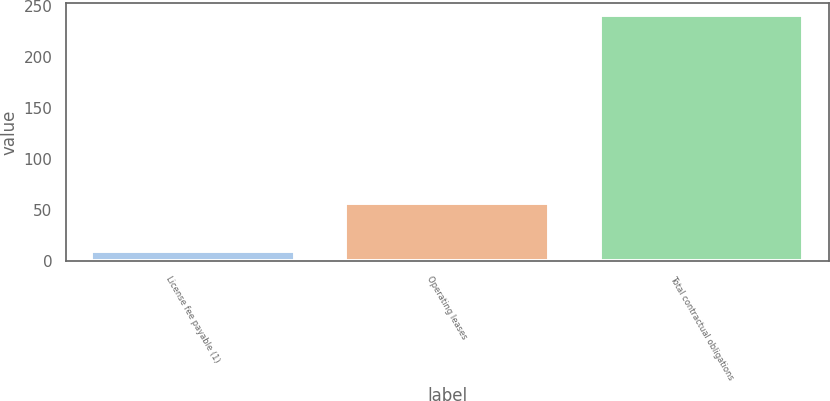<chart> <loc_0><loc_0><loc_500><loc_500><bar_chart><fcel>License fee payable (1)<fcel>Operating leases<fcel>Total contractual obligations<nl><fcel>10<fcel>57<fcel>241<nl></chart> 